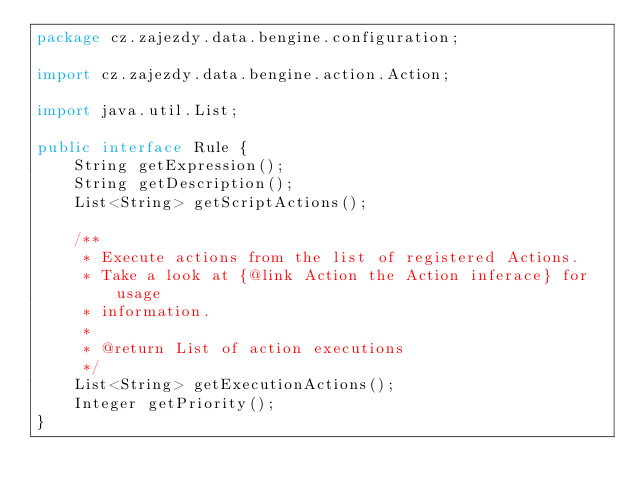Convert code to text. <code><loc_0><loc_0><loc_500><loc_500><_Java_>package cz.zajezdy.data.bengine.configuration;

import cz.zajezdy.data.bengine.action.Action;

import java.util.List;

public interface Rule {
	String getExpression();
	String getDescription();
	List<String> getScriptActions();

	/**
	 * Execute actions from the list of registered Actions.
	 * Take a look at {@link Action the Action inferace} for usage
	 * information.
	 *
	 * @return List of action executions
	 */
	List<String> getExecutionActions();
	Integer getPriority();
}
</code> 